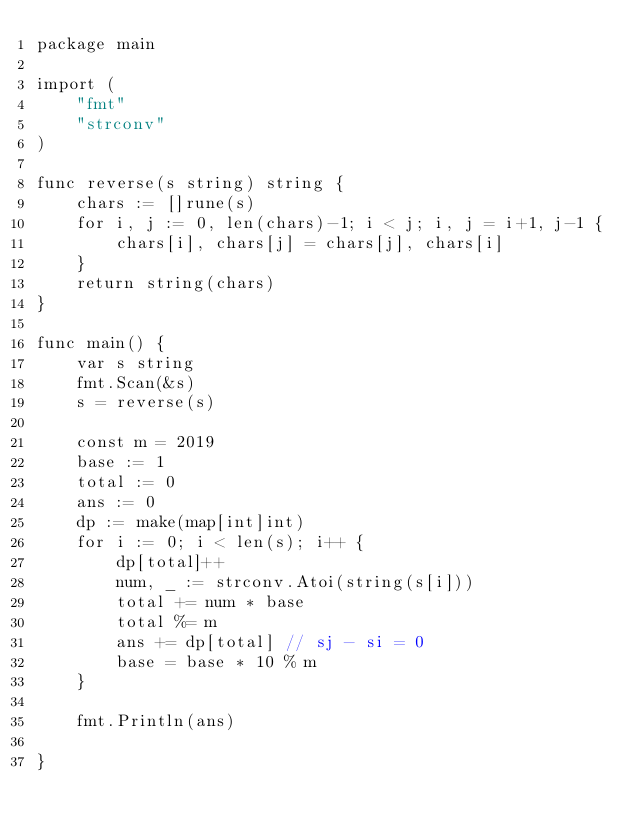<code> <loc_0><loc_0><loc_500><loc_500><_Go_>package main

import (
	"fmt"
	"strconv"
)

func reverse(s string) string {
	chars := []rune(s)
	for i, j := 0, len(chars)-1; i < j; i, j = i+1, j-1 {
		chars[i], chars[j] = chars[j], chars[i]
	}
	return string(chars)
}

func main() {
	var s string
	fmt.Scan(&s)
	s = reverse(s)

	const m = 2019
	base := 1
	total := 0
	ans := 0
	dp := make(map[int]int)
	for i := 0; i < len(s); i++ {
		dp[total]++
		num, _ := strconv.Atoi(string(s[i]))
		total += num * base
		total %= m
		ans += dp[total] // sj - si = 0
		base = base * 10 % m
	}

	fmt.Println(ans)

}</code> 